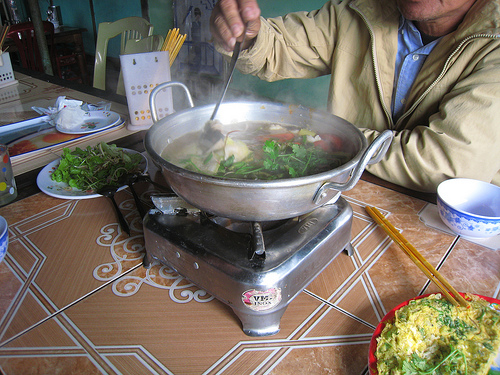<image>
Is the chair to the left of the sticks? No. The chair is not to the left of the sticks. From this viewpoint, they have a different horizontal relationship. 